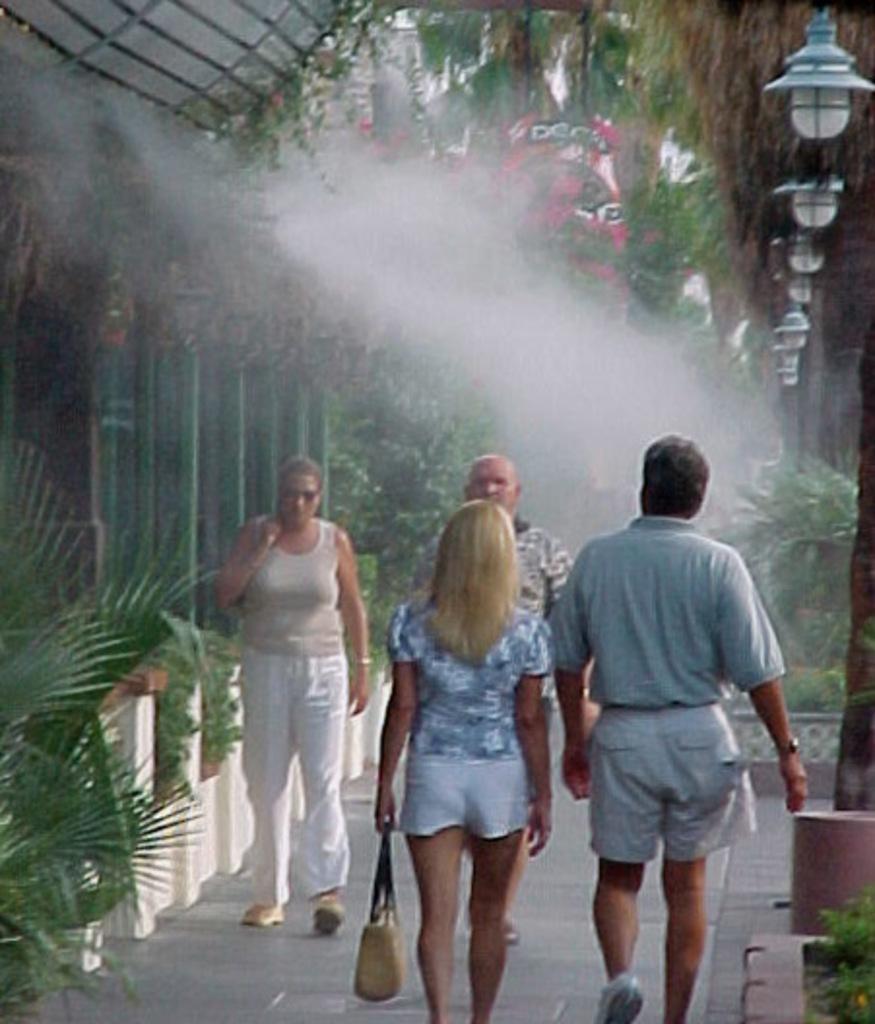Could you give a brief overview of what you see in this image? Here I can see four people are walking on the ground. Two are men and two are women. One woman is holding a bag in the hand. On both sides of the road I can see some plants. On the left side there are few pillars. In the background there are some trees. On the right top I can see few lights. 